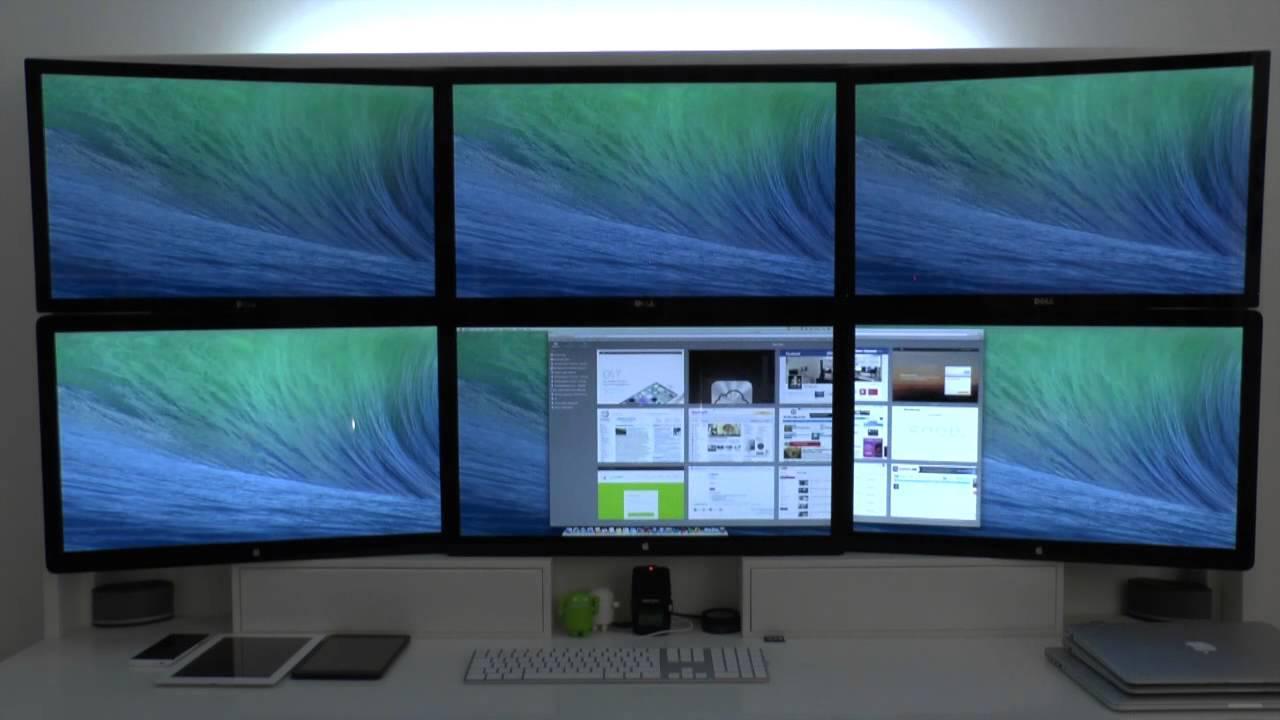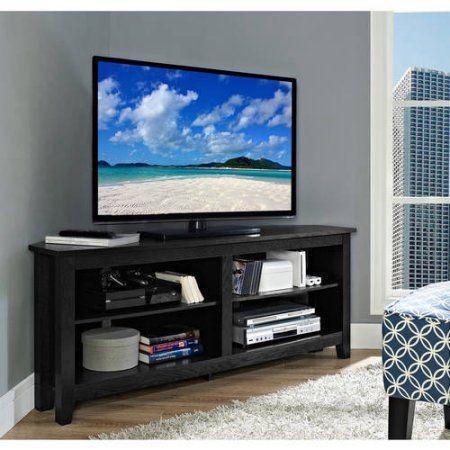The first image is the image on the left, the second image is the image on the right. Given the left and right images, does the statement "There are more screens in the left image than in the right image." hold true? Answer yes or no. Yes. The first image is the image on the left, the second image is the image on the right. Examine the images to the left and right. Is the description "There are multiple monitors in one image, and a TV on a stand in the other image." accurate? Answer yes or no. Yes. 